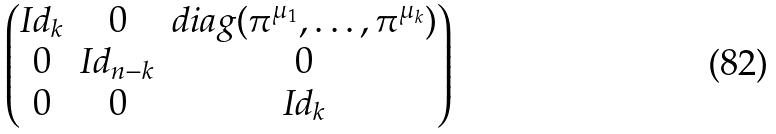<formula> <loc_0><loc_0><loc_500><loc_500>\begin{pmatrix} I d _ { k } & 0 & d i a g ( \pi ^ { \mu _ { 1 } } , \dots , \pi ^ { \mu _ { k } } ) \\ 0 & I d _ { n - k } & 0 \\ 0 & 0 & I d _ { k } \end{pmatrix}</formula> 